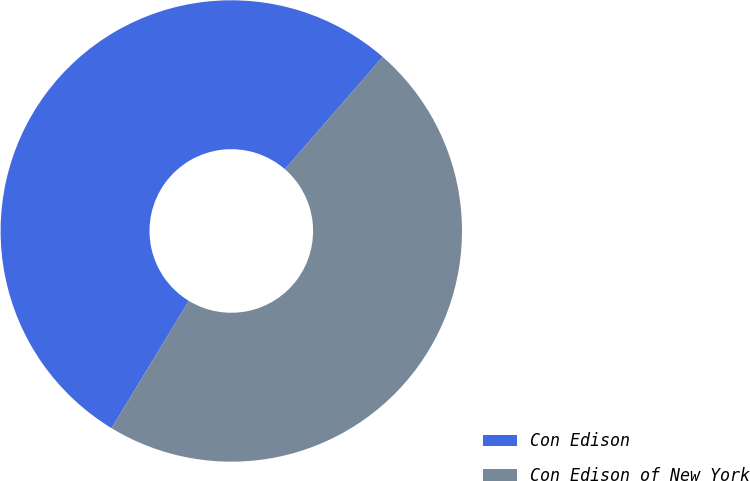Convert chart to OTSL. <chart><loc_0><loc_0><loc_500><loc_500><pie_chart><fcel>Con Edison<fcel>Con Edison of New York<nl><fcel>52.7%<fcel>47.3%<nl></chart> 